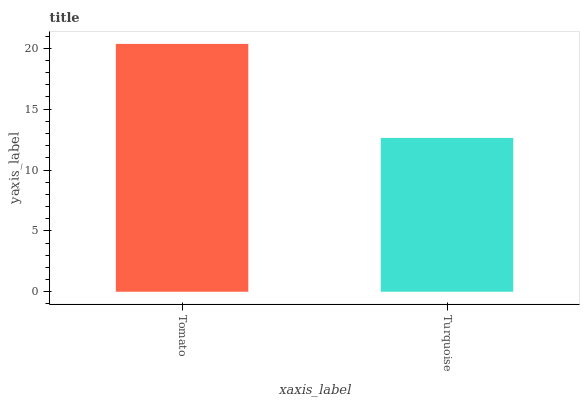Is Turquoise the minimum?
Answer yes or no. Yes. Is Tomato the maximum?
Answer yes or no. Yes. Is Turquoise the maximum?
Answer yes or no. No. Is Tomato greater than Turquoise?
Answer yes or no. Yes. Is Turquoise less than Tomato?
Answer yes or no. Yes. Is Turquoise greater than Tomato?
Answer yes or no. No. Is Tomato less than Turquoise?
Answer yes or no. No. Is Tomato the high median?
Answer yes or no. Yes. Is Turquoise the low median?
Answer yes or no. Yes. Is Turquoise the high median?
Answer yes or no. No. Is Tomato the low median?
Answer yes or no. No. 